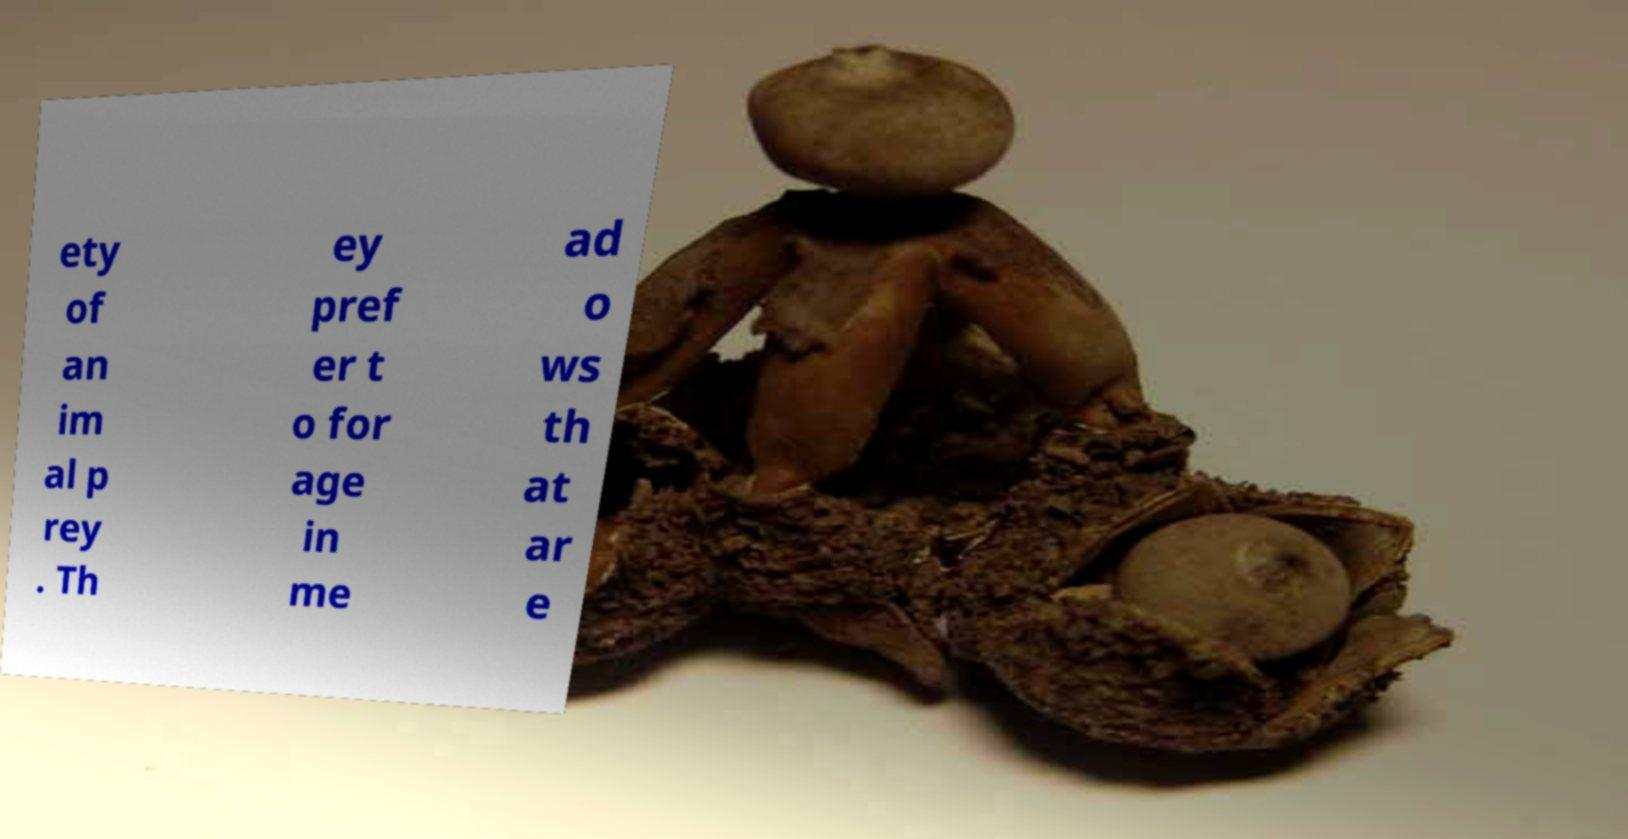There's text embedded in this image that I need extracted. Can you transcribe it verbatim? ety of an im al p rey . Th ey pref er t o for age in me ad o ws th at ar e 